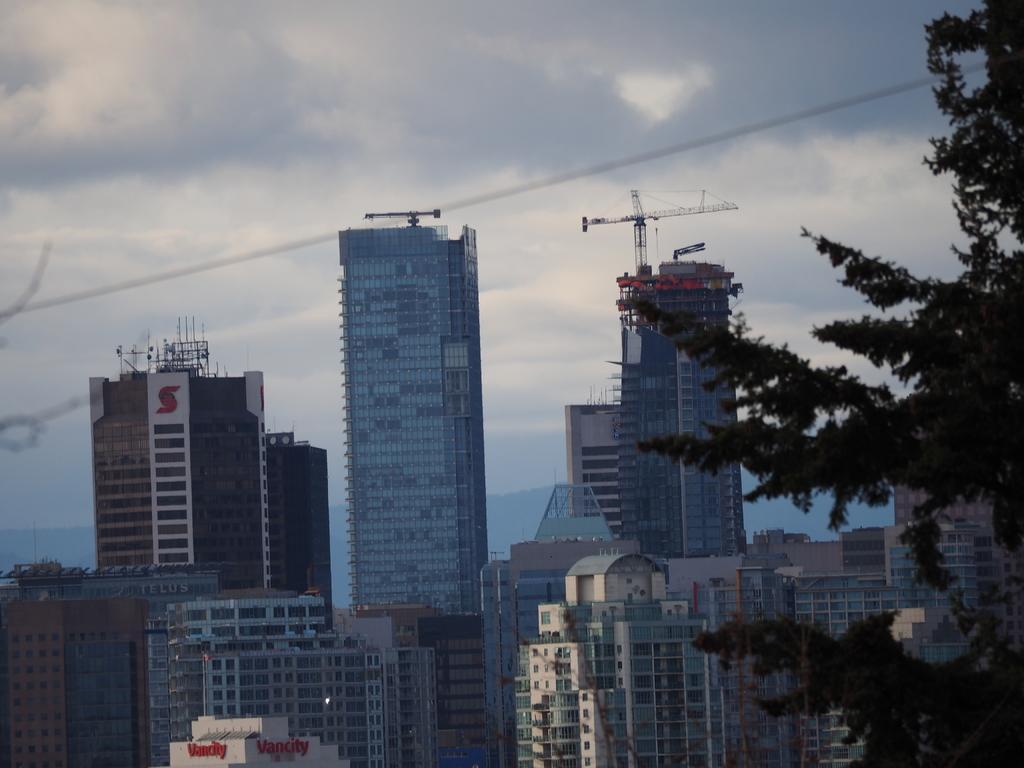Can you describe this image briefly? In this picture I can see some buildings and trees. 